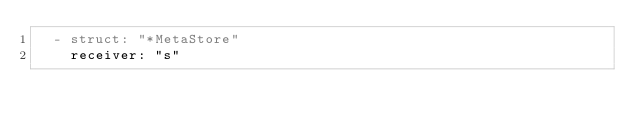Convert code to text. <code><loc_0><loc_0><loc_500><loc_500><_YAML_>  - struct: "*MetaStore"
    receiver: "s"</code> 